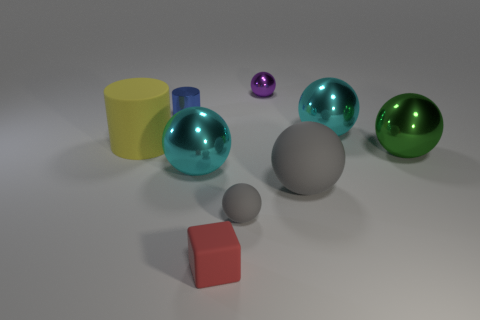Is the tiny purple shiny object the same shape as the blue metal object?
Your answer should be very brief. No. There is another object that is the same shape as the blue metal object; what is its material?
Keep it short and to the point. Rubber. Is there a tiny matte block on the right side of the purple ball that is behind the tiny metallic thing on the left side of the red matte block?
Your answer should be very brief. No. Do the large green thing and the large matte thing right of the matte cube have the same shape?
Keep it short and to the point. Yes. Is there anything else of the same color as the tiny shiny sphere?
Give a very brief answer. No. There is a rubber object behind the big gray object; is it the same color as the small ball behind the large yellow rubber thing?
Offer a very short reply. No. Are there any green metallic cylinders?
Make the answer very short. No. Are there any big brown blocks made of the same material as the large gray sphere?
Your answer should be compact. No. The block has what color?
Keep it short and to the point. Red. There is a matte thing that is the same color as the large matte sphere; what is its shape?
Keep it short and to the point. Sphere. 